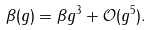<formula> <loc_0><loc_0><loc_500><loc_500>\beta ( g ) = \beta g ^ { 3 } + \mathcal { O } ( g ^ { 5 } ) .</formula> 